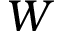<formula> <loc_0><loc_0><loc_500><loc_500>W</formula> 